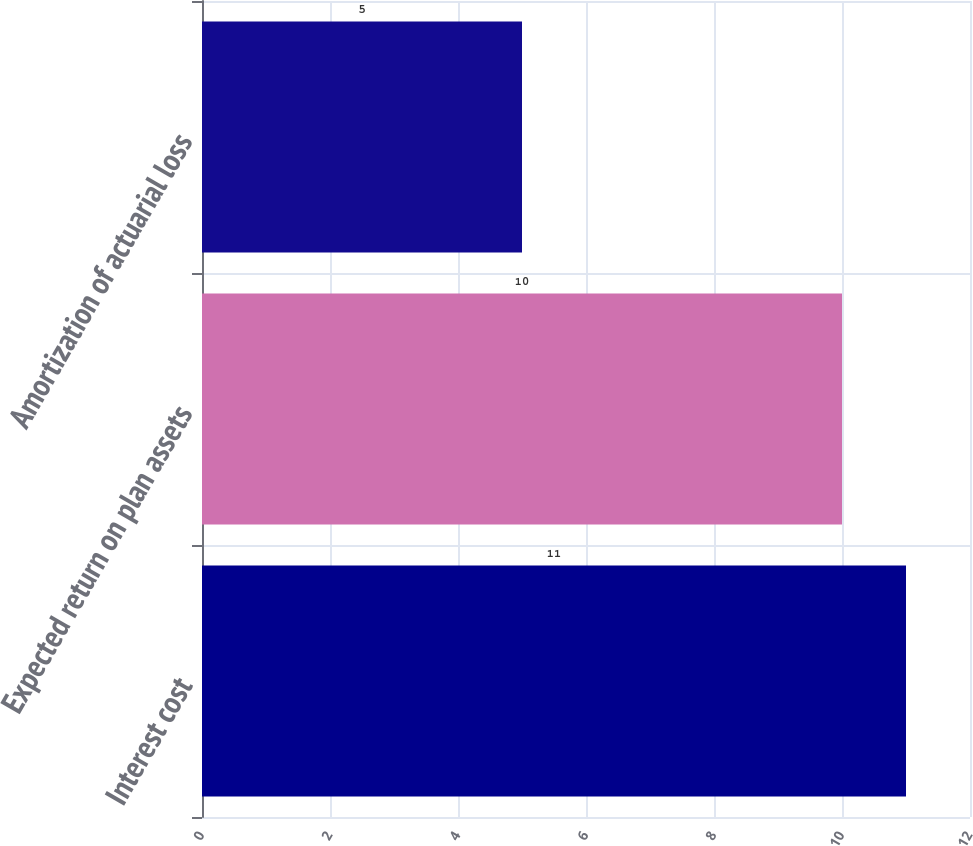Convert chart. <chart><loc_0><loc_0><loc_500><loc_500><bar_chart><fcel>Interest cost<fcel>Expected return on plan assets<fcel>Amortization of actuarial loss<nl><fcel>11<fcel>10<fcel>5<nl></chart> 